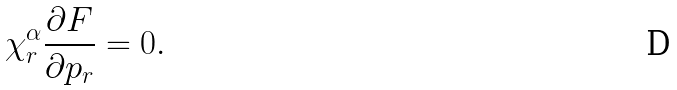Convert formula to latex. <formula><loc_0><loc_0><loc_500><loc_500>\chi ^ { \alpha } _ { r } \frac { \partial F } { \partial p _ { r } } = 0 .</formula> 